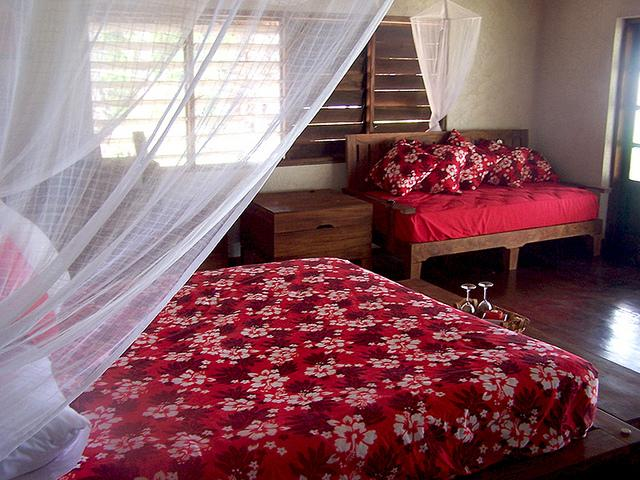What holiday is the color pattern on the bed most appropriate for? Please explain your reasoning. valentines day. The color pattern on the bed is red and very appropriate for valentine's day. 